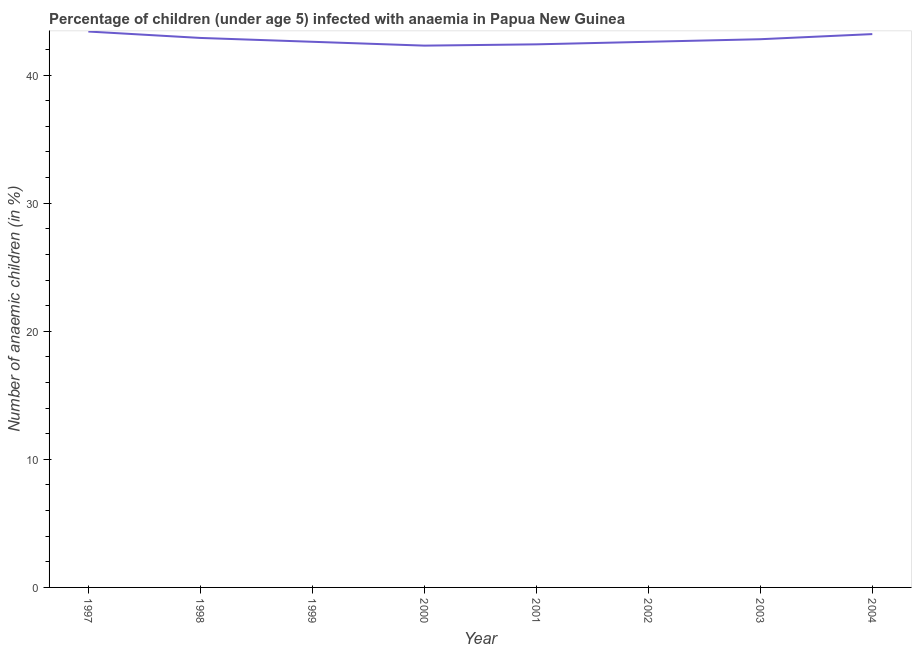What is the number of anaemic children in 1997?
Your answer should be compact. 43.4. Across all years, what is the maximum number of anaemic children?
Keep it short and to the point. 43.4. Across all years, what is the minimum number of anaemic children?
Give a very brief answer. 42.3. In which year was the number of anaemic children minimum?
Provide a short and direct response. 2000. What is the sum of the number of anaemic children?
Your answer should be compact. 342.2. What is the difference between the number of anaemic children in 1997 and 2002?
Offer a very short reply. 0.8. What is the average number of anaemic children per year?
Your response must be concise. 42.77. What is the median number of anaemic children?
Your answer should be very brief. 42.7. Do a majority of the years between 1998 and 2000 (inclusive) have number of anaemic children greater than 8 %?
Offer a terse response. Yes. What is the ratio of the number of anaemic children in 2002 to that in 2004?
Keep it short and to the point. 0.99. Is the number of anaemic children in 1997 less than that in 2001?
Offer a terse response. No. Is the difference between the number of anaemic children in 1998 and 2000 greater than the difference between any two years?
Provide a succinct answer. No. What is the difference between the highest and the second highest number of anaemic children?
Offer a terse response. 0.2. Is the sum of the number of anaemic children in 1997 and 2004 greater than the maximum number of anaemic children across all years?
Your answer should be very brief. Yes. What is the difference between the highest and the lowest number of anaemic children?
Offer a very short reply. 1.1. How many lines are there?
Offer a very short reply. 1. How many years are there in the graph?
Keep it short and to the point. 8. What is the difference between two consecutive major ticks on the Y-axis?
Offer a terse response. 10. Does the graph contain grids?
Ensure brevity in your answer.  No. What is the title of the graph?
Make the answer very short. Percentage of children (under age 5) infected with anaemia in Papua New Guinea. What is the label or title of the Y-axis?
Your answer should be very brief. Number of anaemic children (in %). What is the Number of anaemic children (in %) in 1997?
Offer a very short reply. 43.4. What is the Number of anaemic children (in %) of 1998?
Your response must be concise. 42.9. What is the Number of anaemic children (in %) in 1999?
Provide a short and direct response. 42.6. What is the Number of anaemic children (in %) of 2000?
Ensure brevity in your answer.  42.3. What is the Number of anaemic children (in %) of 2001?
Your response must be concise. 42.4. What is the Number of anaemic children (in %) in 2002?
Your response must be concise. 42.6. What is the Number of anaemic children (in %) of 2003?
Offer a very short reply. 42.8. What is the Number of anaemic children (in %) of 2004?
Offer a very short reply. 43.2. What is the difference between the Number of anaemic children (in %) in 1997 and 1999?
Ensure brevity in your answer.  0.8. What is the difference between the Number of anaemic children (in %) in 1997 and 2000?
Your answer should be very brief. 1.1. What is the difference between the Number of anaemic children (in %) in 1997 and 2001?
Your response must be concise. 1. What is the difference between the Number of anaemic children (in %) in 1997 and 2002?
Keep it short and to the point. 0.8. What is the difference between the Number of anaemic children (in %) in 1997 and 2003?
Your answer should be very brief. 0.6. What is the difference between the Number of anaemic children (in %) in 1997 and 2004?
Make the answer very short. 0.2. What is the difference between the Number of anaemic children (in %) in 1998 and 1999?
Offer a very short reply. 0.3. What is the difference between the Number of anaemic children (in %) in 1998 and 2001?
Ensure brevity in your answer.  0.5. What is the difference between the Number of anaemic children (in %) in 1998 and 2003?
Keep it short and to the point. 0.1. What is the difference between the Number of anaemic children (in %) in 1998 and 2004?
Offer a very short reply. -0.3. What is the difference between the Number of anaemic children (in %) in 1999 and 2001?
Make the answer very short. 0.2. What is the difference between the Number of anaemic children (in %) in 1999 and 2003?
Offer a terse response. -0.2. What is the difference between the Number of anaemic children (in %) in 2000 and 2001?
Your response must be concise. -0.1. What is the difference between the Number of anaemic children (in %) in 2000 and 2002?
Offer a terse response. -0.3. What is the difference between the Number of anaemic children (in %) in 2000 and 2004?
Your answer should be compact. -0.9. What is the difference between the Number of anaemic children (in %) in 2001 and 2003?
Your answer should be compact. -0.4. What is the difference between the Number of anaemic children (in %) in 2001 and 2004?
Make the answer very short. -0.8. What is the difference between the Number of anaemic children (in %) in 2002 and 2004?
Provide a succinct answer. -0.6. What is the difference between the Number of anaemic children (in %) in 2003 and 2004?
Keep it short and to the point. -0.4. What is the ratio of the Number of anaemic children (in %) in 1997 to that in 1999?
Keep it short and to the point. 1.02. What is the ratio of the Number of anaemic children (in %) in 1997 to that in 2003?
Make the answer very short. 1.01. What is the ratio of the Number of anaemic children (in %) in 1997 to that in 2004?
Your answer should be compact. 1. What is the ratio of the Number of anaemic children (in %) in 1998 to that in 1999?
Ensure brevity in your answer.  1.01. What is the ratio of the Number of anaemic children (in %) in 1998 to that in 2001?
Give a very brief answer. 1.01. What is the ratio of the Number of anaemic children (in %) in 1999 to that in 2000?
Offer a terse response. 1.01. What is the ratio of the Number of anaemic children (in %) in 1999 to that in 2004?
Offer a very short reply. 0.99. What is the ratio of the Number of anaemic children (in %) in 2000 to that in 2003?
Offer a terse response. 0.99. What is the ratio of the Number of anaemic children (in %) in 2000 to that in 2004?
Offer a very short reply. 0.98. What is the ratio of the Number of anaemic children (in %) in 2001 to that in 2002?
Make the answer very short. 0.99. What is the ratio of the Number of anaemic children (in %) in 2002 to that in 2004?
Your response must be concise. 0.99. 